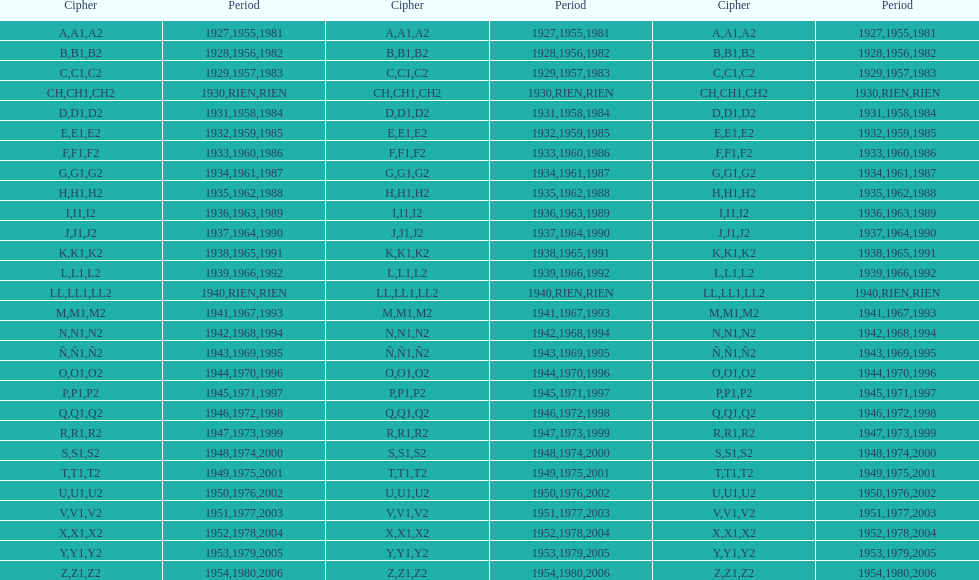What was the lowest year stamped? 1927. 